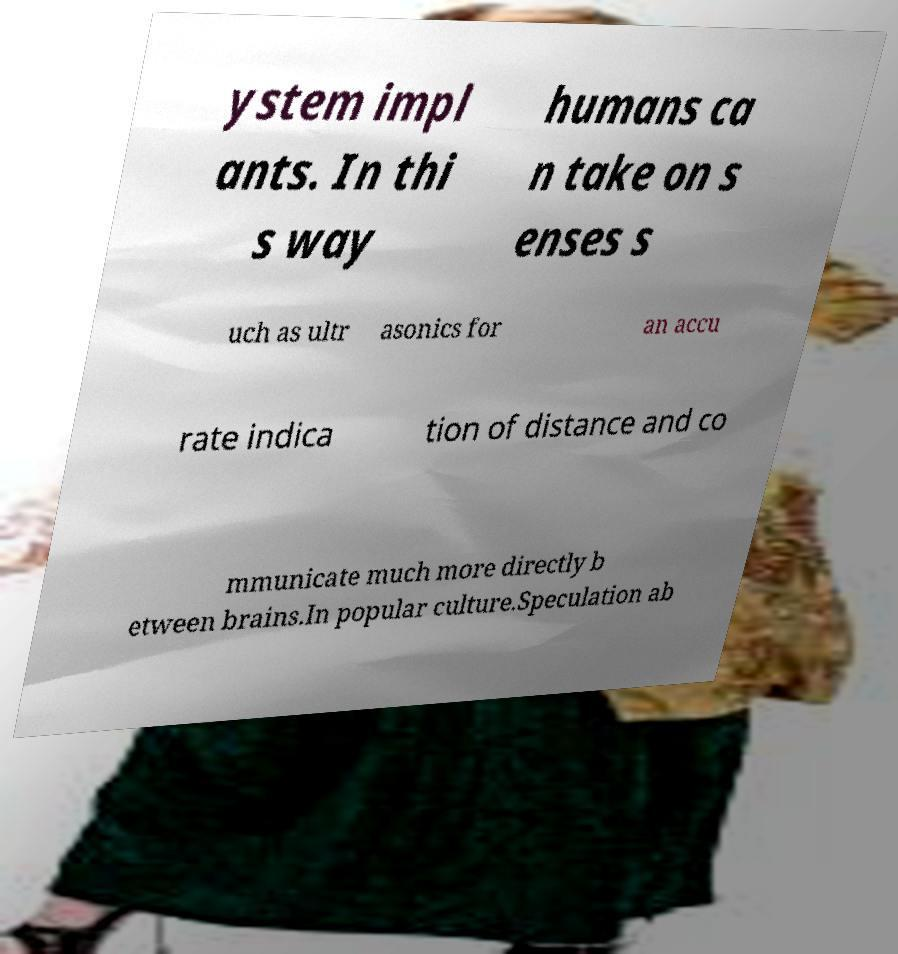For documentation purposes, I need the text within this image transcribed. Could you provide that? ystem impl ants. In thi s way humans ca n take on s enses s uch as ultr asonics for an accu rate indica tion of distance and co mmunicate much more directly b etween brains.In popular culture.Speculation ab 